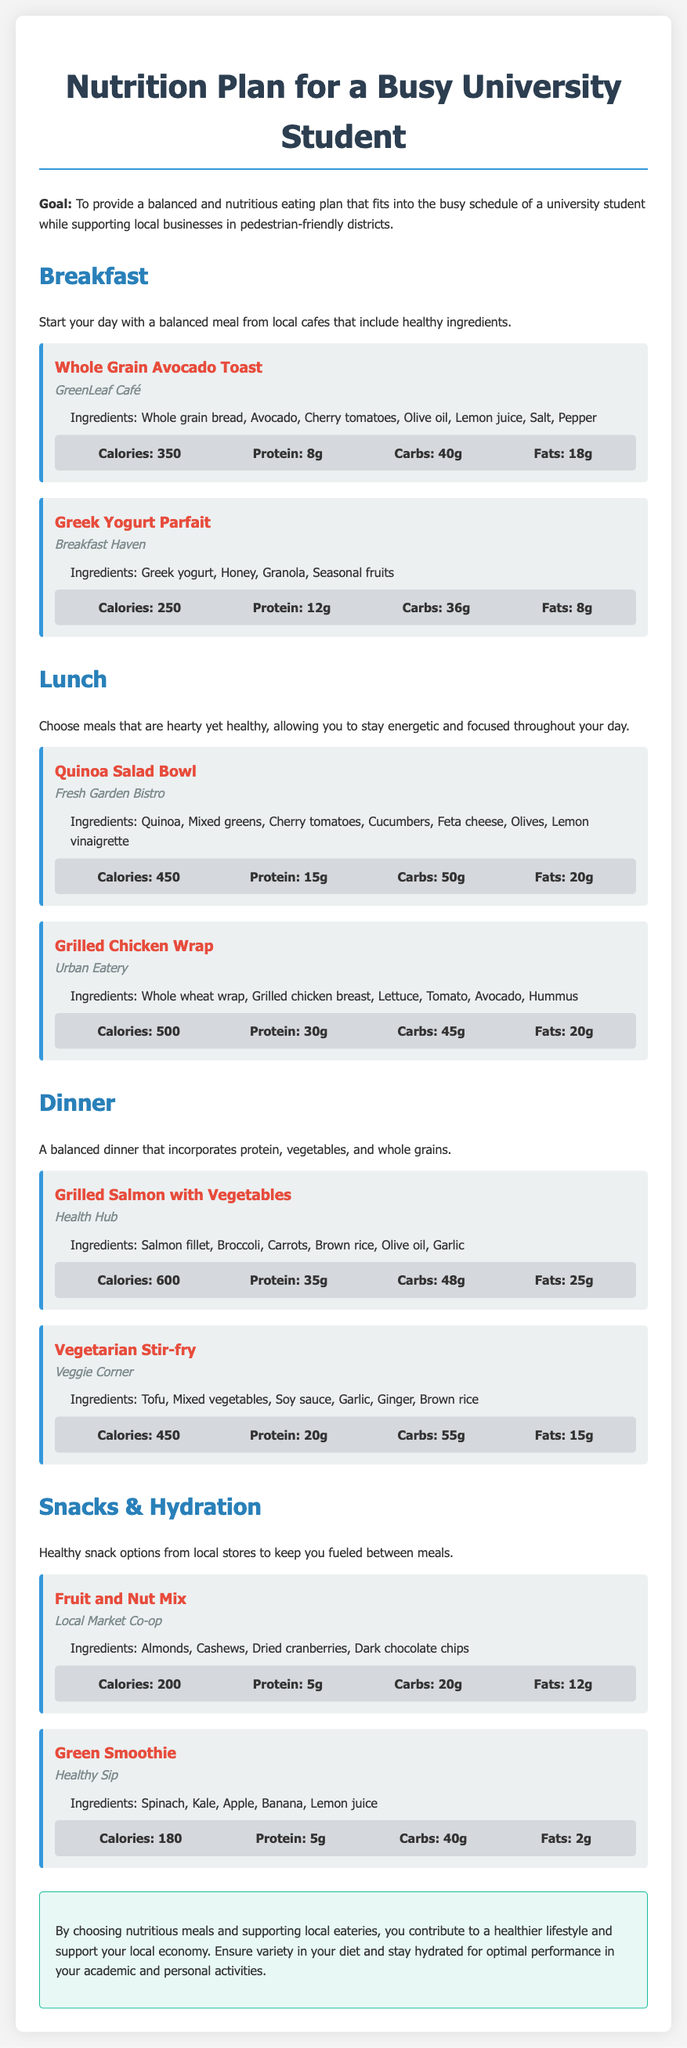What is the goal of the nutrition plan? The goal is to provide a balanced and nutritious eating plan that fits into the busy schedule of a university student while supporting local businesses in pedestrian-friendly districts.
Answer: To provide a balanced and nutritious eating plan that fits into the busy schedule of a university student while supporting local businesses in pedestrian-friendly districts Which café offers the Whole Grain Avocado Toast? The Whole Grain Avocado Toast is served at GreenLeaf Café.
Answer: GreenLeaf Café How many grams of protein are in the Greek Yogurt Parfait? The Greek Yogurt Parfait contains 12 grams of protein.
Answer: 12g What type of wrap is used in the Grilled Chicken Wrap? The wrap used in the Grilled Chicken Wrap is whole wheat.
Answer: Whole wheat wrap What is included in the ingredients for the Grilled Salmon with Vegetables? The ingredients for Grilled Salmon with Vegetables include Salmon fillet, Broccoli, Carrots, Brown rice, Olive oil, Garlic.
Answer: Salmon fillet, Broccoli, Carrots, Brown rice, Olive oil, Garlic How much fat is in the Vegetarian Stir-fry? The Vegetarian Stir-fry contains 15 grams of fat.
Answer: 15g What is a suggested healthy snack option? A suggested healthy snack option is the Fruit and Nut Mix.
Answer: Fruit and Nut Mix What is the total calorie count for the Quinoa Salad Bowl? The Quinoa Salad Bowl has a total of 450 calories.
Answer: 450 Which local market offers the Green Smoothie? The Green Smoothie is offered at Healthy Sip.
Answer: Healthy Sip 